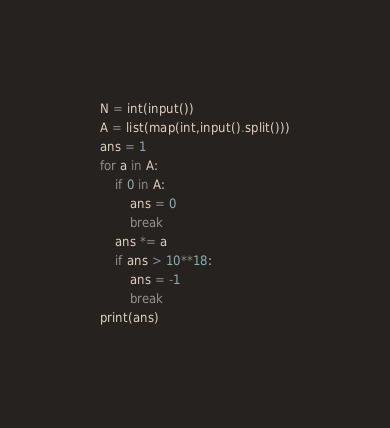<code> <loc_0><loc_0><loc_500><loc_500><_Python_>N = int(input())
A = list(map(int,input().split()))
ans = 1
for a in A:
    if 0 in A:
        ans = 0
        break
    ans *= a
    if ans > 10**18:
        ans = -1
        break
print(ans)</code> 